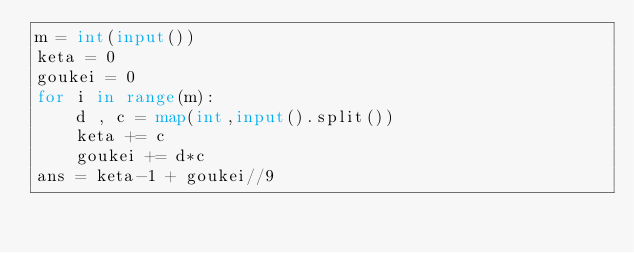Convert code to text. <code><loc_0><loc_0><loc_500><loc_500><_Python_>m = int(input())
keta = 0
goukei = 0
for i in range(m):
    d , c = map(int,input().split())
    keta += c
    goukei += d*c
ans = keta-1 + goukei//9
</code> 